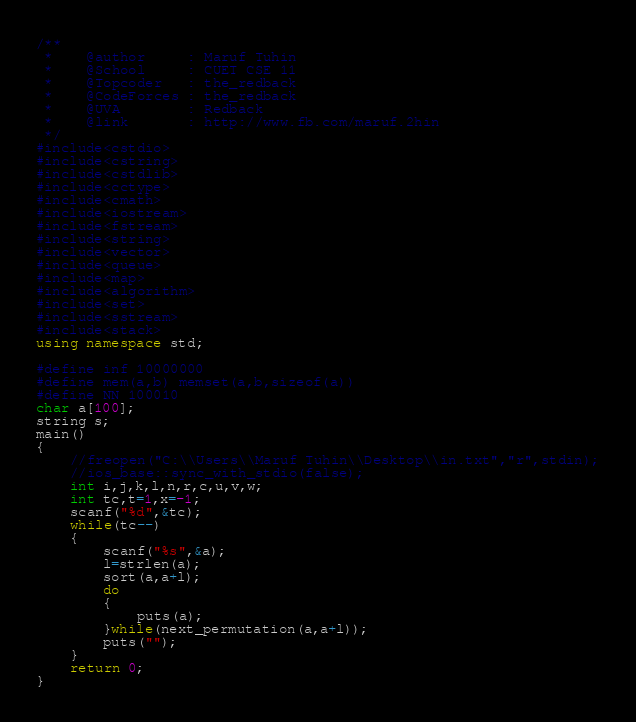Convert code to text. <code><loc_0><loc_0><loc_500><loc_500><_C++_>/**
 *    @author     : Maruf Tuhin
 *    @School     : CUET CSE 11
 *    @Topcoder   : the_redback
 *    @CodeForces : the_redback
 *    @UVA        : Redback
 *    @link       : http://www.fb.com/maruf.2hin
 */
#include<cstdio>
#include<cstring>
#include<cstdlib>
#include<cctype>
#include<cmath>
#include<iostream>
#include<fstream>
#include<string>
#include<vector>
#include<queue>
#include<map>
#include<algorithm>
#include<set>
#include<sstream>
#include<stack>
using namespace std;

#define inf 10000000
#define mem(a,b) memset(a,b,sizeof(a))
#define NN 100010
char a[100];
string s;
main()
{
    //freopen("C:\\Users\\Maruf Tuhin\\Desktop\\in.txt","r",stdin);
    //ios_base::sync_with_stdio(false);
    int i,j,k,l,n,r,c,u,v,w;
    int tc,t=1,x=-1;
    scanf("%d",&tc);
    while(tc--)
    {
        scanf("%s",&a);
        l=strlen(a);
        sort(a,a+l);
        do
        {
            puts(a);
        }while(next_permutation(a,a+l));
        puts("");
    }
    return 0;
}






</code> 